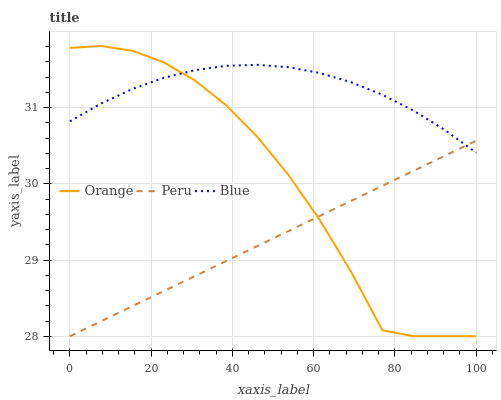Does Blue have the minimum area under the curve?
Answer yes or no. No. Does Peru have the maximum area under the curve?
Answer yes or no. No. Is Blue the smoothest?
Answer yes or no. No. Is Blue the roughest?
Answer yes or no. No. Does Blue have the lowest value?
Answer yes or no. No. Does Blue have the highest value?
Answer yes or no. No. 